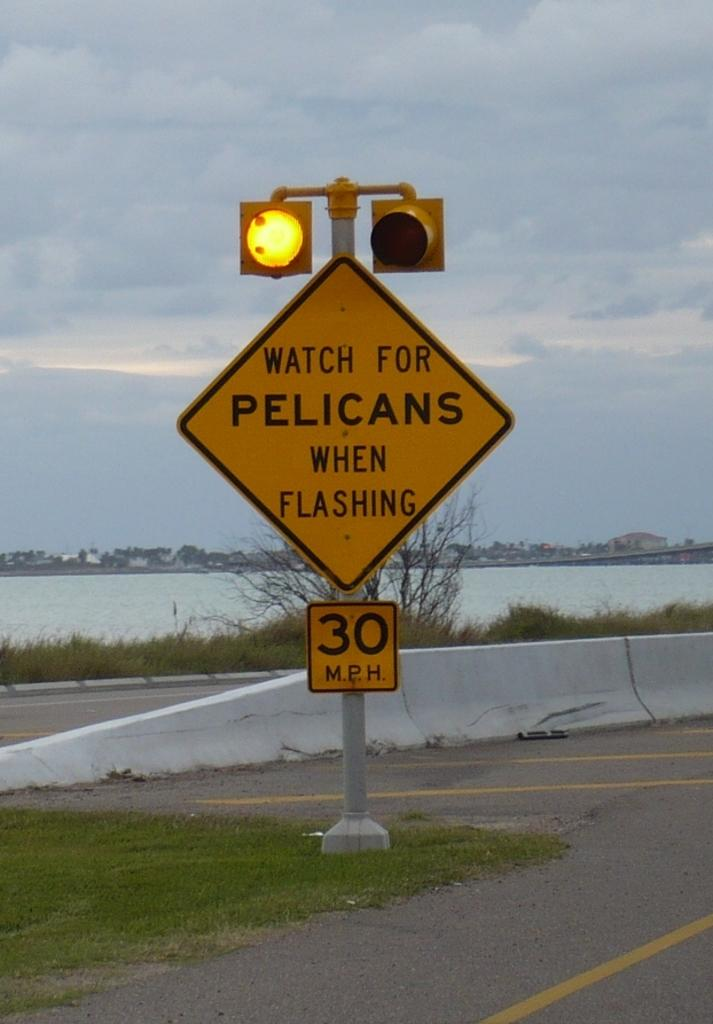Provide a one-sentence caption for the provided image. The flashing light warns motorists to watch out for pelicans. 